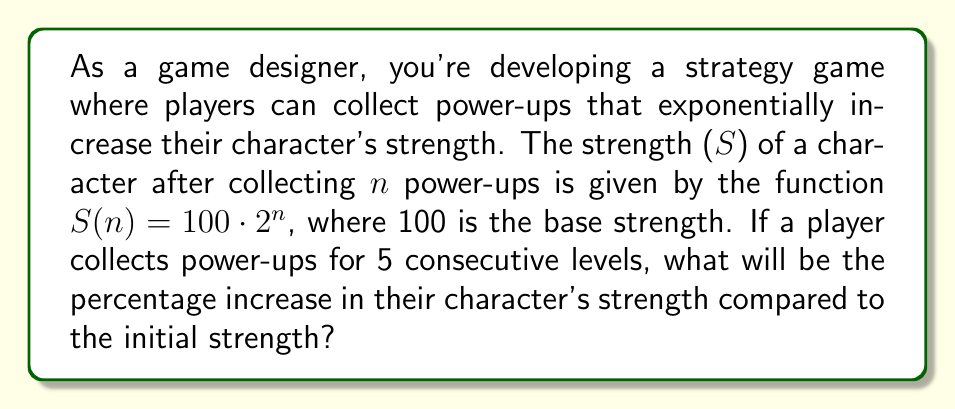Provide a solution to this math problem. Let's approach this step-by-step:

1) The initial strength (when n = 0) is:
   $S(0) = 100 \cdot 2^0 = 100$

2) After 5 levels (n = 5), the strength becomes:
   $S(5) = 100 \cdot 2^5 = 100 \cdot 32 = 3200$

3) To calculate the percentage increase, we use the formula:
   $\text{Percentage increase} = \frac{\text{Increase}}{\text{Original}} \times 100\%$

4) The increase in strength is:
   $3200 - 100 = 3100$

5) Applying the formula:
   $$\text{Percentage increase} = \frac{3100}{100} \times 100\% = 31 \times 100\% = 3100\%$$

This exponential growth demonstrates the powerful effect of cumulative power-ups in game design, which can significantly impact game balance and player strategy.
Answer: 3100% 